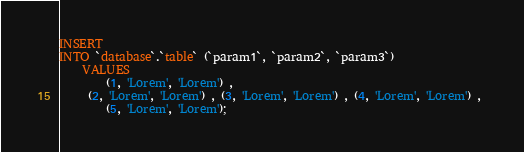Convert code to text. <code><loc_0><loc_0><loc_500><loc_500><_SQL_>INSERT 
INTO `database`.`table` (`param1`, `param2`, `param3`) 
	VALUES 
		(1, 'Lorem', 'Lorem') ,
	 (2, 'Lorem', 'Lorem') , (3, 'Lorem', 'Lorem') , (4, 'Lorem', 'Lorem') , 
		(5, 'Lorem', 'Lorem');</code> 